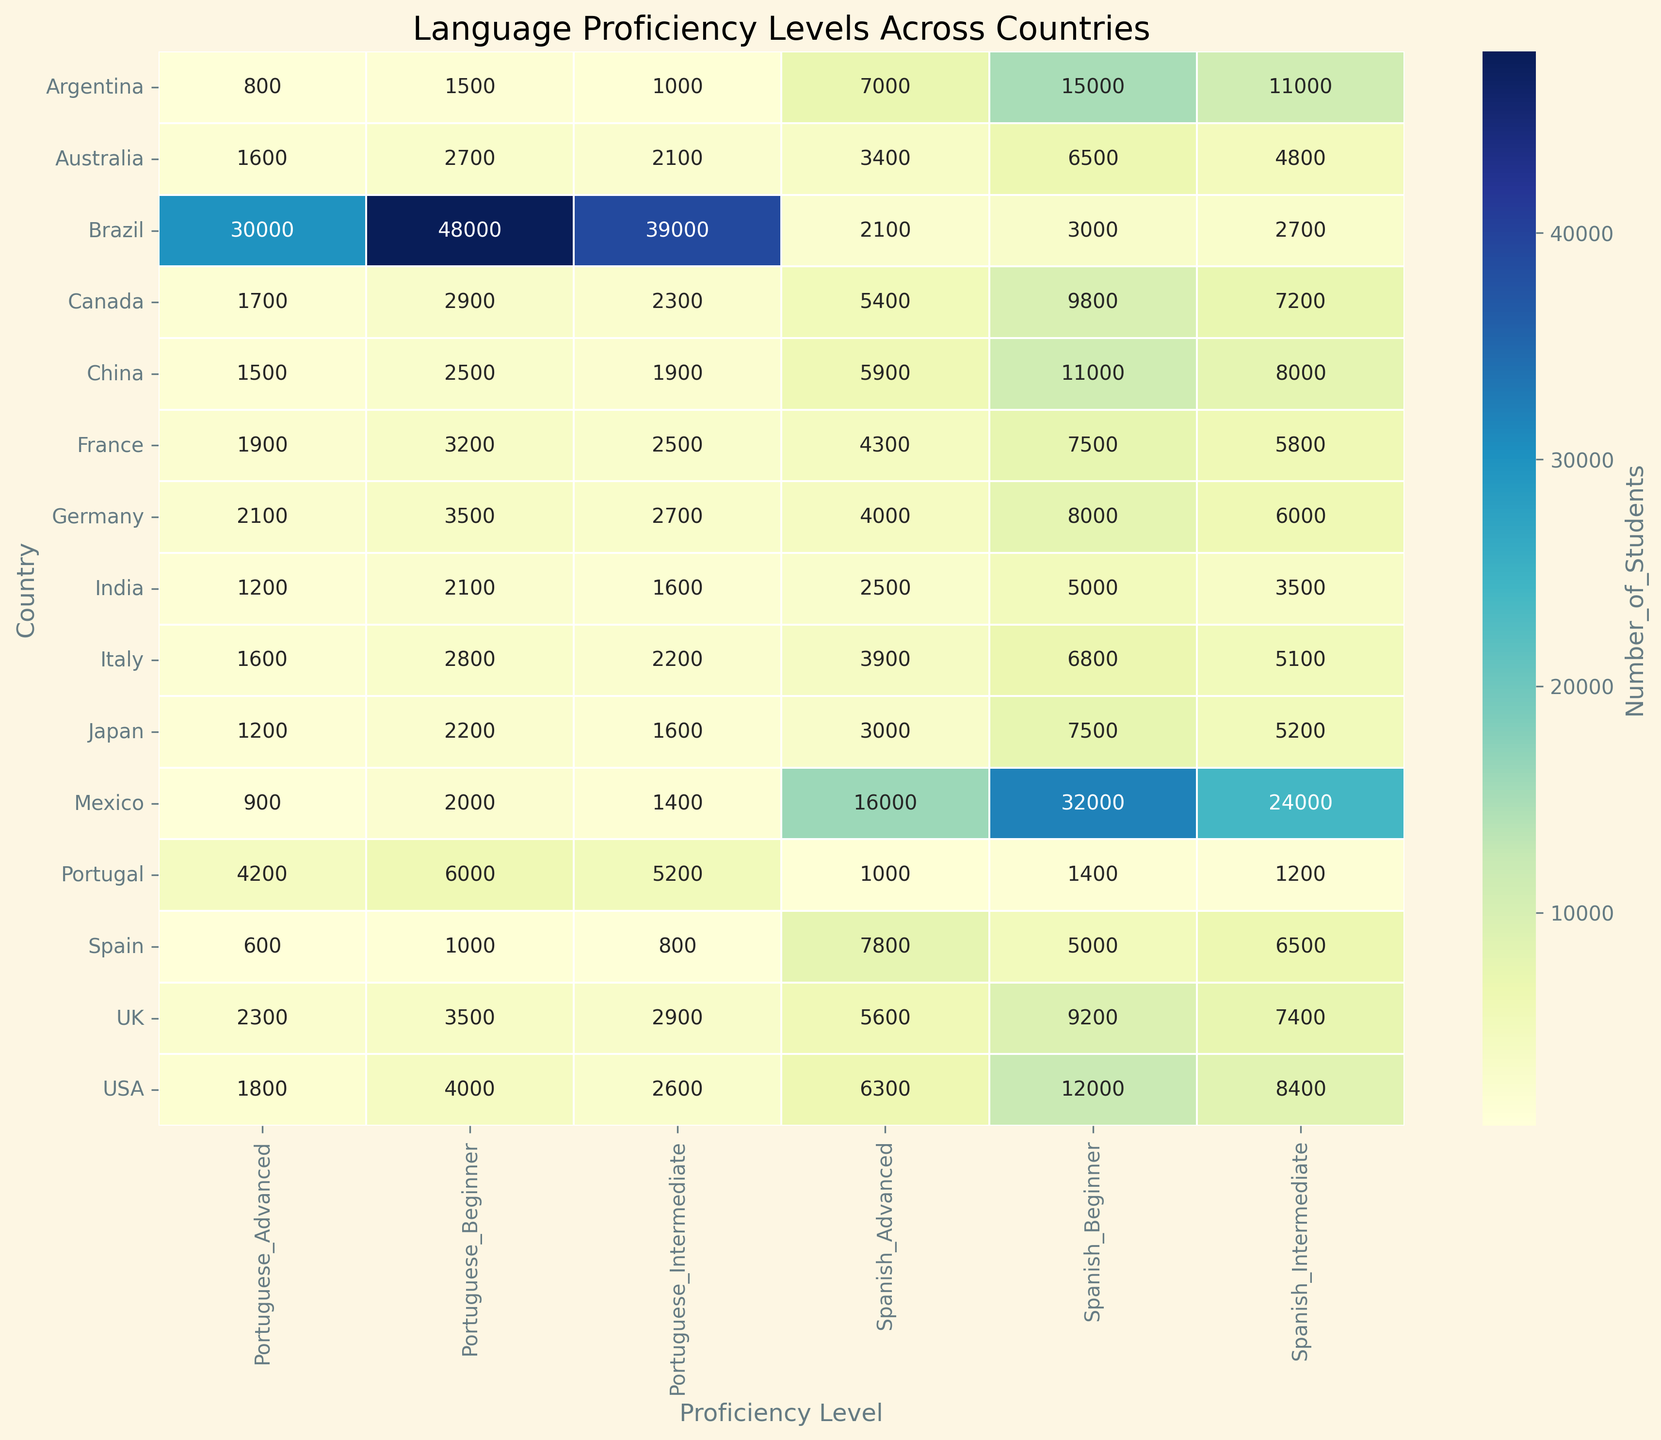What country has the highest number of Spanish learners at the beginner level? To find out the country with the highest number of Spanish learners at the beginner level, look at the 'Spanish_Beginner' column and identify the country with the highest value. The USA has the highest value in this category.
Answer: USA Which country has more Portuguese advanced learners: Canada or Japan? Compare the values in the 'Portuguese_Advanced' row for Canada and Japan. Canada has 1700 and Japan has 1200, so Canada has more Portuguese advanced learners.
Answer: Canada What is the total number of advanced learners of Spanish in Europe (Spain, Germany, France, UK, Italy)? Sum the 'Spanish_Advanced' values for Spain, Germany, France, UK, and Italy. Spain (7800) + Germany (4000) + France (4300) + UK (5600) + Italy (3900) = 25600.
Answer: 25600 Is the number of Spanish intermediate learners in Mexico greater than the number of Portuguese intermediate learners in Brazil? Compare 'Spanish_Intermediate' in Mexico (24000) with 'Portuguese_Intermediate' in Brazil (39000). Since 24000 is less than 39000, the answer is no.
Answer: No Which proficiency level of learners has the most students in Brazil overall? Compare the values for Spanish and Portuguese at all proficiency levels for Brazil. The highest number is 48000 for Portuguese beginners.
Answer: Portuguese_Beginner What is the average number of Spanish intermediate learners in the USA, China, and India? Sum the 'Spanish_Intermediate' values for USA (8400), China (8000), and India (3500) and divide by 3. (8400 + 8000 + 3500) / 3 = 6633.33.
Answer: 6633.33 Which country has the lowest number of Portuguese beginners? Look at the 'Portuguese_Beginner' column to find the lowest value. Spain has 1000 which is the lowest.
Answer: Spain How does the number of Spanish advanced learners in Argentina compare to the number of Portuguese advanced learners in Portugal? Compare 'Spanish_Advanced' in Argentina (7000) with 'Portuguese_Advanced' in Portugal (4200). Argentina has more advanced learners.
Answer: Argentina What is the total number of learners (all levels) in Australia? Sum all values for Australia: 6500 (Spanish_Beginner) + 4800 (Spanish_Intermediate) + 3400 (Spanish_Advanced) + 2700 (Portuguese_Beginner) + 2100 (Portuguese_Intermediate) + 1600 (Portuguese_Advanced) = 21100.
Answer: 21100 Is there any country where the number of Portuguese learners exceeds the number of Spanish learners at all proficiency levels? Compare the sum of all Portuguese learners to the sum of all Spanish learners for each country. In Brazil, 48000 (Portuguese_Beginner) + 39000 (Portuguese_Intermediate) + 30000 (Portuguese_Advanced) = 117000 exceeds 3000 + 2700 + 2100 = 7800 (sum of all Spanish learners).
Answer: Yes in Brazil 